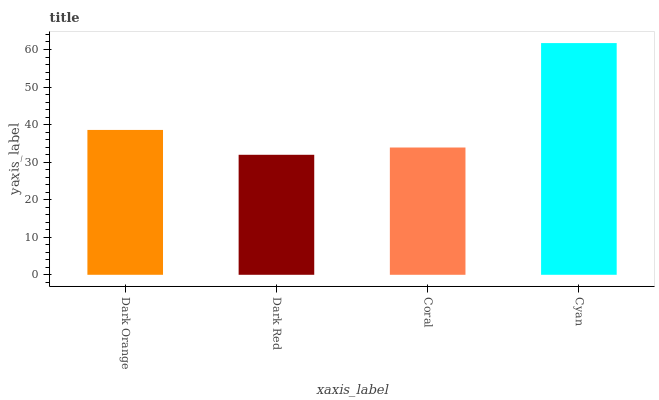Is Coral the minimum?
Answer yes or no. No. Is Coral the maximum?
Answer yes or no. No. Is Coral greater than Dark Red?
Answer yes or no. Yes. Is Dark Red less than Coral?
Answer yes or no. Yes. Is Dark Red greater than Coral?
Answer yes or no. No. Is Coral less than Dark Red?
Answer yes or no. No. Is Dark Orange the high median?
Answer yes or no. Yes. Is Coral the low median?
Answer yes or no. Yes. Is Dark Red the high median?
Answer yes or no. No. Is Cyan the low median?
Answer yes or no. No. 